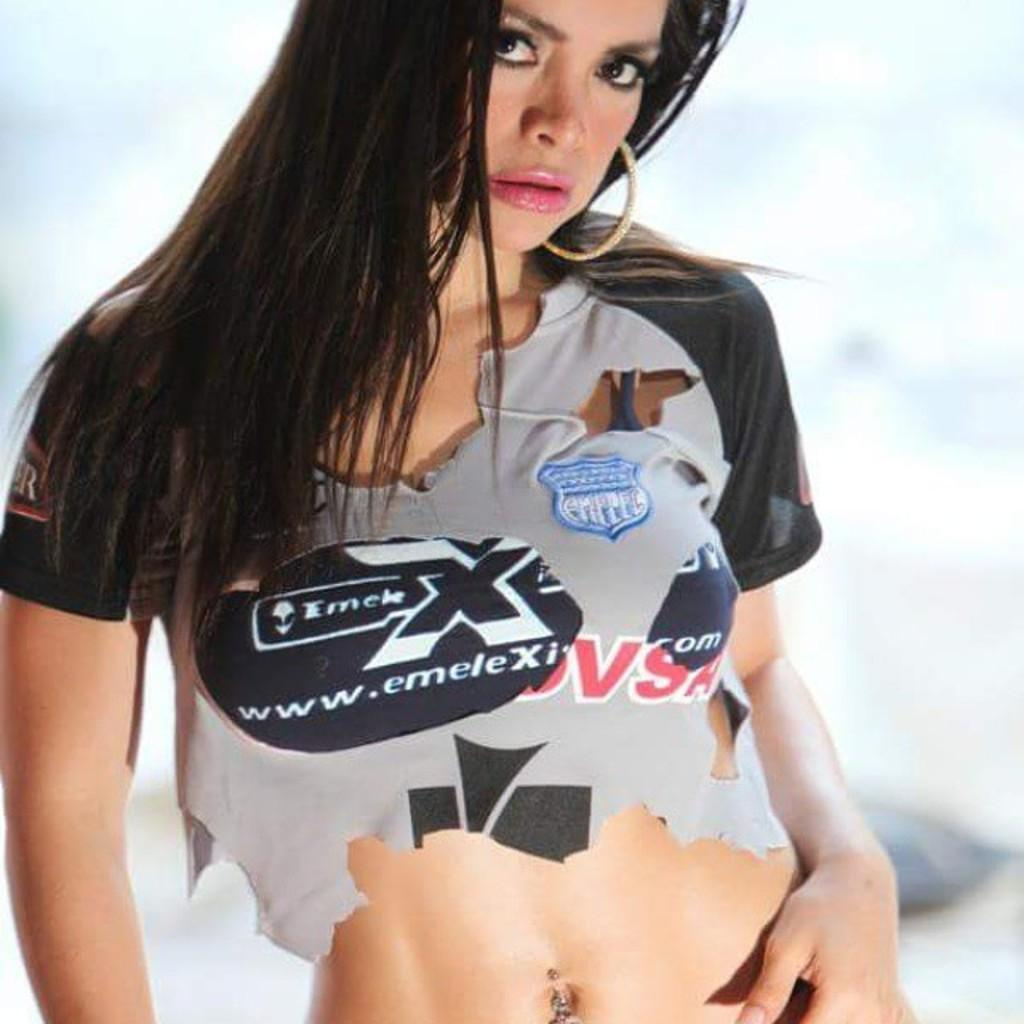<image>
Describe the image concisely. The woman is wearing a t-shirt with the url for emele. 